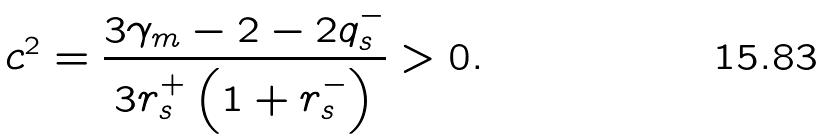Convert formula to latex. <formula><loc_0><loc_0><loc_500><loc_500>c ^ { 2 } = \frac { 3 \gamma _ { m } - 2 - 2 q _ { s } ^ { - } } { 3 r _ { s } ^ { + } \left ( 1 + r _ { s } ^ { - } \right ) } > 0 .</formula> 